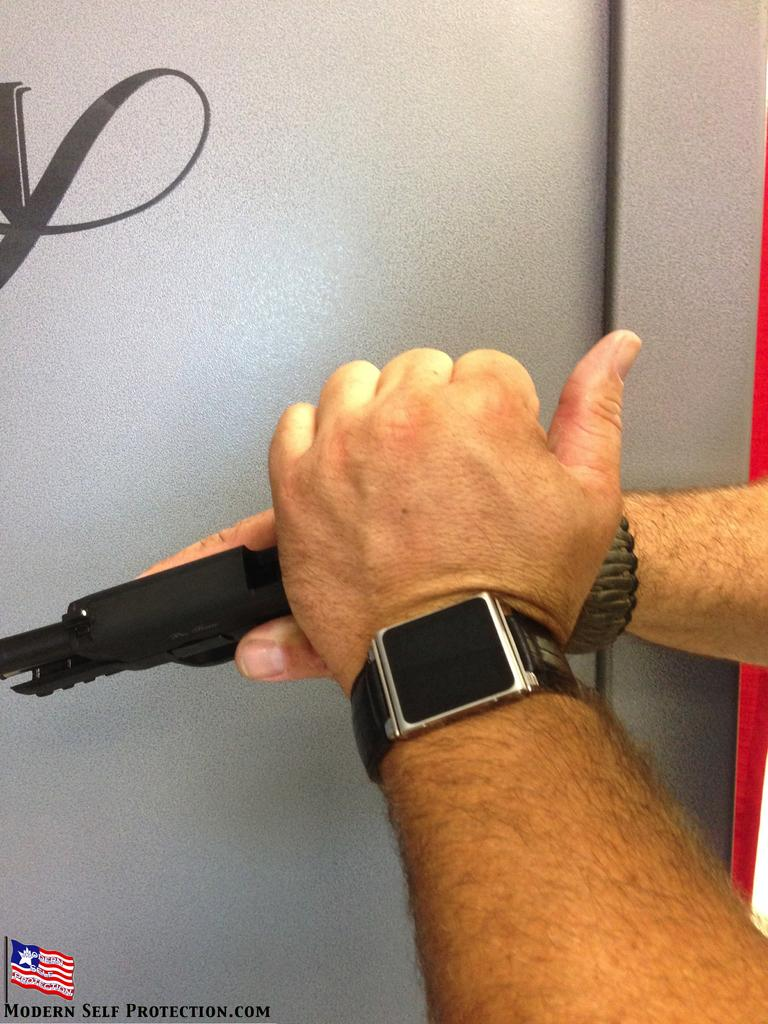Provide a one-sentence caption for the provided image. A man cocking a gun, the website promoting this is modernselfprotection.com. 